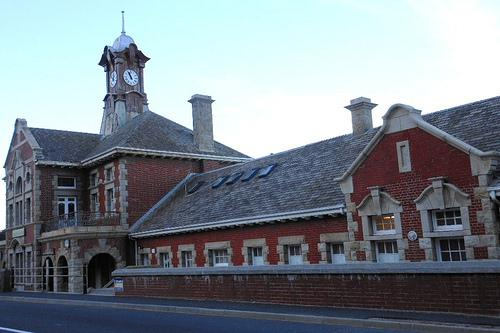Question: who took this picture?
Choices:
A. A child.
B. A stranger.
C. A man.
D. A photographer.
Answer with the letter. Answer: D Question: what is in this picture?
Choices:
A. A house.
B. A mountain.
C. The sky.
D. A building.
Answer with the letter. Answer: D Question: what is in the top tower?
Choices:
A. A clock.
B. Cameras.
C. Lights.
D. A guard.
Answer with the letter. Answer: A 